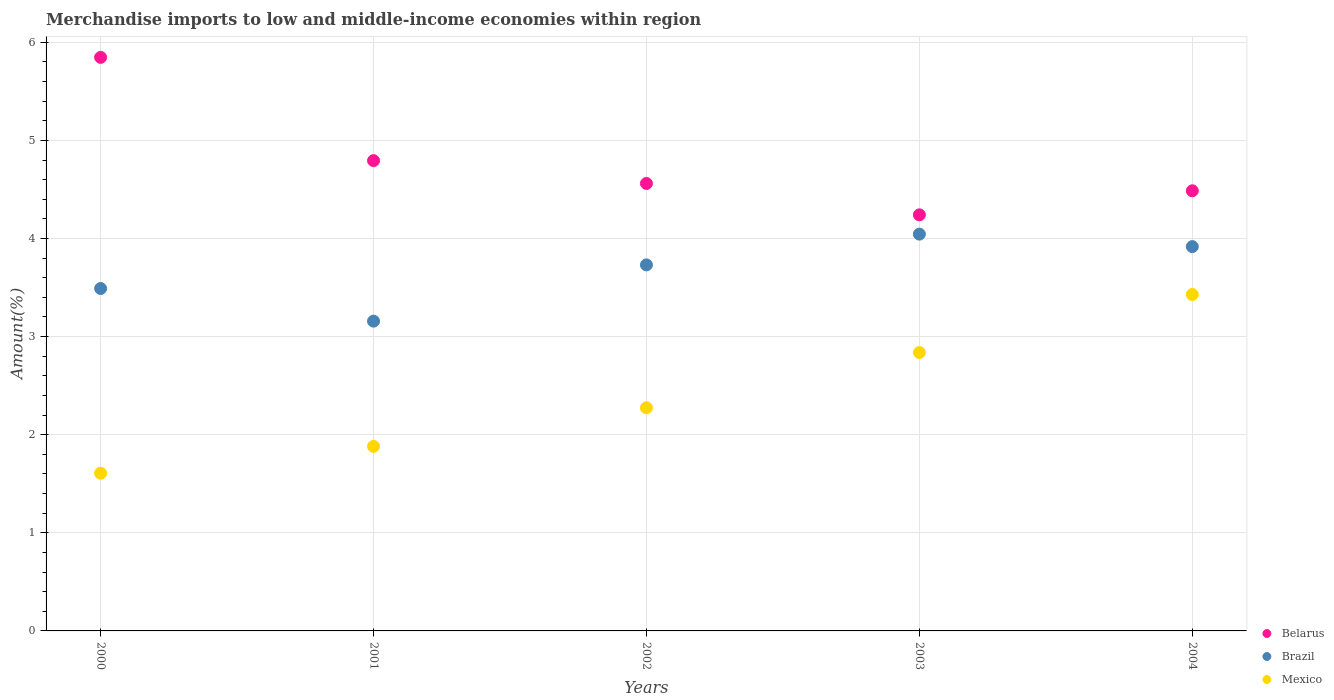Is the number of dotlines equal to the number of legend labels?
Offer a very short reply. Yes. What is the percentage of amount earned from merchandise imports in Brazil in 2004?
Your answer should be compact. 3.92. Across all years, what is the maximum percentage of amount earned from merchandise imports in Brazil?
Offer a very short reply. 4.04. Across all years, what is the minimum percentage of amount earned from merchandise imports in Mexico?
Give a very brief answer. 1.61. In which year was the percentage of amount earned from merchandise imports in Mexico maximum?
Your answer should be very brief. 2004. In which year was the percentage of amount earned from merchandise imports in Belarus minimum?
Your answer should be compact. 2003. What is the total percentage of amount earned from merchandise imports in Mexico in the graph?
Keep it short and to the point. 12.03. What is the difference between the percentage of amount earned from merchandise imports in Belarus in 2000 and that in 2004?
Give a very brief answer. 1.36. What is the difference between the percentage of amount earned from merchandise imports in Brazil in 2004 and the percentage of amount earned from merchandise imports in Mexico in 2003?
Make the answer very short. 1.08. What is the average percentage of amount earned from merchandise imports in Brazil per year?
Offer a very short reply. 3.67. In the year 2003, what is the difference between the percentage of amount earned from merchandise imports in Brazil and percentage of amount earned from merchandise imports in Belarus?
Ensure brevity in your answer.  -0.2. In how many years, is the percentage of amount earned from merchandise imports in Mexico greater than 2.4 %?
Give a very brief answer. 2. What is the ratio of the percentage of amount earned from merchandise imports in Mexico in 2001 to that in 2002?
Your answer should be very brief. 0.83. What is the difference between the highest and the second highest percentage of amount earned from merchandise imports in Mexico?
Offer a terse response. 0.59. What is the difference between the highest and the lowest percentage of amount earned from merchandise imports in Brazil?
Your answer should be very brief. 0.89. In how many years, is the percentage of amount earned from merchandise imports in Brazil greater than the average percentage of amount earned from merchandise imports in Brazil taken over all years?
Keep it short and to the point. 3. Does the percentage of amount earned from merchandise imports in Brazil monotonically increase over the years?
Give a very brief answer. No. Is the percentage of amount earned from merchandise imports in Brazil strictly less than the percentage of amount earned from merchandise imports in Mexico over the years?
Offer a terse response. No. How many years are there in the graph?
Provide a short and direct response. 5. Are the values on the major ticks of Y-axis written in scientific E-notation?
Ensure brevity in your answer.  No. Does the graph contain grids?
Offer a terse response. Yes. Where does the legend appear in the graph?
Keep it short and to the point. Bottom right. How many legend labels are there?
Offer a terse response. 3. How are the legend labels stacked?
Give a very brief answer. Vertical. What is the title of the graph?
Provide a short and direct response. Merchandise imports to low and middle-income economies within region. What is the label or title of the X-axis?
Your answer should be compact. Years. What is the label or title of the Y-axis?
Offer a terse response. Amount(%). What is the Amount(%) of Belarus in 2000?
Your response must be concise. 5.85. What is the Amount(%) in Brazil in 2000?
Ensure brevity in your answer.  3.49. What is the Amount(%) in Mexico in 2000?
Your answer should be very brief. 1.61. What is the Amount(%) of Belarus in 2001?
Provide a succinct answer. 4.79. What is the Amount(%) of Brazil in 2001?
Your answer should be compact. 3.16. What is the Amount(%) in Mexico in 2001?
Offer a very short reply. 1.88. What is the Amount(%) in Belarus in 2002?
Your answer should be compact. 4.56. What is the Amount(%) of Brazil in 2002?
Provide a succinct answer. 3.73. What is the Amount(%) in Mexico in 2002?
Your answer should be compact. 2.27. What is the Amount(%) in Belarus in 2003?
Offer a terse response. 4.24. What is the Amount(%) of Brazil in 2003?
Your answer should be very brief. 4.04. What is the Amount(%) in Mexico in 2003?
Keep it short and to the point. 2.84. What is the Amount(%) in Belarus in 2004?
Your answer should be very brief. 4.49. What is the Amount(%) in Brazil in 2004?
Your response must be concise. 3.92. What is the Amount(%) of Mexico in 2004?
Your response must be concise. 3.43. Across all years, what is the maximum Amount(%) of Belarus?
Offer a terse response. 5.85. Across all years, what is the maximum Amount(%) of Brazil?
Keep it short and to the point. 4.04. Across all years, what is the maximum Amount(%) of Mexico?
Provide a short and direct response. 3.43. Across all years, what is the minimum Amount(%) of Belarus?
Provide a short and direct response. 4.24. Across all years, what is the minimum Amount(%) in Brazil?
Your answer should be compact. 3.16. Across all years, what is the minimum Amount(%) of Mexico?
Your answer should be very brief. 1.61. What is the total Amount(%) in Belarus in the graph?
Your answer should be very brief. 23.93. What is the total Amount(%) of Brazil in the graph?
Your response must be concise. 18.34. What is the total Amount(%) of Mexico in the graph?
Provide a short and direct response. 12.03. What is the difference between the Amount(%) of Belarus in 2000 and that in 2001?
Your response must be concise. 1.05. What is the difference between the Amount(%) in Brazil in 2000 and that in 2001?
Provide a short and direct response. 0.33. What is the difference between the Amount(%) in Mexico in 2000 and that in 2001?
Your response must be concise. -0.27. What is the difference between the Amount(%) in Belarus in 2000 and that in 2002?
Give a very brief answer. 1.29. What is the difference between the Amount(%) in Brazil in 2000 and that in 2002?
Your answer should be compact. -0.24. What is the difference between the Amount(%) in Mexico in 2000 and that in 2002?
Your response must be concise. -0.67. What is the difference between the Amount(%) of Belarus in 2000 and that in 2003?
Give a very brief answer. 1.61. What is the difference between the Amount(%) in Brazil in 2000 and that in 2003?
Give a very brief answer. -0.55. What is the difference between the Amount(%) in Mexico in 2000 and that in 2003?
Your response must be concise. -1.23. What is the difference between the Amount(%) of Belarus in 2000 and that in 2004?
Give a very brief answer. 1.36. What is the difference between the Amount(%) of Brazil in 2000 and that in 2004?
Ensure brevity in your answer.  -0.43. What is the difference between the Amount(%) of Mexico in 2000 and that in 2004?
Keep it short and to the point. -1.82. What is the difference between the Amount(%) in Belarus in 2001 and that in 2002?
Ensure brevity in your answer.  0.23. What is the difference between the Amount(%) in Brazil in 2001 and that in 2002?
Offer a terse response. -0.57. What is the difference between the Amount(%) in Mexico in 2001 and that in 2002?
Offer a terse response. -0.39. What is the difference between the Amount(%) of Belarus in 2001 and that in 2003?
Provide a short and direct response. 0.55. What is the difference between the Amount(%) of Brazil in 2001 and that in 2003?
Your answer should be compact. -0.89. What is the difference between the Amount(%) of Mexico in 2001 and that in 2003?
Ensure brevity in your answer.  -0.96. What is the difference between the Amount(%) in Belarus in 2001 and that in 2004?
Your response must be concise. 0.31. What is the difference between the Amount(%) in Brazil in 2001 and that in 2004?
Provide a short and direct response. -0.76. What is the difference between the Amount(%) in Mexico in 2001 and that in 2004?
Provide a succinct answer. -1.55. What is the difference between the Amount(%) in Belarus in 2002 and that in 2003?
Provide a short and direct response. 0.32. What is the difference between the Amount(%) of Brazil in 2002 and that in 2003?
Offer a very short reply. -0.31. What is the difference between the Amount(%) in Mexico in 2002 and that in 2003?
Offer a terse response. -0.56. What is the difference between the Amount(%) in Belarus in 2002 and that in 2004?
Offer a very short reply. 0.07. What is the difference between the Amount(%) in Brazil in 2002 and that in 2004?
Keep it short and to the point. -0.19. What is the difference between the Amount(%) of Mexico in 2002 and that in 2004?
Provide a short and direct response. -1.15. What is the difference between the Amount(%) in Belarus in 2003 and that in 2004?
Keep it short and to the point. -0.25. What is the difference between the Amount(%) of Brazil in 2003 and that in 2004?
Your answer should be compact. 0.13. What is the difference between the Amount(%) in Mexico in 2003 and that in 2004?
Provide a succinct answer. -0.59. What is the difference between the Amount(%) of Belarus in 2000 and the Amount(%) of Brazil in 2001?
Give a very brief answer. 2.69. What is the difference between the Amount(%) in Belarus in 2000 and the Amount(%) in Mexico in 2001?
Provide a succinct answer. 3.97. What is the difference between the Amount(%) in Brazil in 2000 and the Amount(%) in Mexico in 2001?
Offer a very short reply. 1.61. What is the difference between the Amount(%) in Belarus in 2000 and the Amount(%) in Brazil in 2002?
Your answer should be compact. 2.12. What is the difference between the Amount(%) of Belarus in 2000 and the Amount(%) of Mexico in 2002?
Offer a terse response. 3.57. What is the difference between the Amount(%) in Brazil in 2000 and the Amount(%) in Mexico in 2002?
Offer a terse response. 1.22. What is the difference between the Amount(%) of Belarus in 2000 and the Amount(%) of Brazil in 2003?
Keep it short and to the point. 1.8. What is the difference between the Amount(%) of Belarus in 2000 and the Amount(%) of Mexico in 2003?
Make the answer very short. 3.01. What is the difference between the Amount(%) in Brazil in 2000 and the Amount(%) in Mexico in 2003?
Your answer should be compact. 0.65. What is the difference between the Amount(%) of Belarus in 2000 and the Amount(%) of Brazil in 2004?
Offer a terse response. 1.93. What is the difference between the Amount(%) in Belarus in 2000 and the Amount(%) in Mexico in 2004?
Your answer should be very brief. 2.42. What is the difference between the Amount(%) in Brazil in 2000 and the Amount(%) in Mexico in 2004?
Offer a terse response. 0.06. What is the difference between the Amount(%) of Belarus in 2001 and the Amount(%) of Brazil in 2002?
Provide a succinct answer. 1.06. What is the difference between the Amount(%) in Belarus in 2001 and the Amount(%) in Mexico in 2002?
Your answer should be very brief. 2.52. What is the difference between the Amount(%) of Brazil in 2001 and the Amount(%) of Mexico in 2002?
Your answer should be compact. 0.88. What is the difference between the Amount(%) of Belarus in 2001 and the Amount(%) of Brazil in 2003?
Keep it short and to the point. 0.75. What is the difference between the Amount(%) of Belarus in 2001 and the Amount(%) of Mexico in 2003?
Your answer should be compact. 1.96. What is the difference between the Amount(%) in Brazil in 2001 and the Amount(%) in Mexico in 2003?
Offer a terse response. 0.32. What is the difference between the Amount(%) of Belarus in 2001 and the Amount(%) of Brazil in 2004?
Keep it short and to the point. 0.88. What is the difference between the Amount(%) of Belarus in 2001 and the Amount(%) of Mexico in 2004?
Offer a very short reply. 1.36. What is the difference between the Amount(%) in Brazil in 2001 and the Amount(%) in Mexico in 2004?
Offer a very short reply. -0.27. What is the difference between the Amount(%) in Belarus in 2002 and the Amount(%) in Brazil in 2003?
Ensure brevity in your answer.  0.52. What is the difference between the Amount(%) in Belarus in 2002 and the Amount(%) in Mexico in 2003?
Your answer should be very brief. 1.72. What is the difference between the Amount(%) in Brazil in 2002 and the Amount(%) in Mexico in 2003?
Offer a very short reply. 0.89. What is the difference between the Amount(%) in Belarus in 2002 and the Amount(%) in Brazil in 2004?
Make the answer very short. 0.64. What is the difference between the Amount(%) in Belarus in 2002 and the Amount(%) in Mexico in 2004?
Offer a very short reply. 1.13. What is the difference between the Amount(%) in Brazil in 2002 and the Amount(%) in Mexico in 2004?
Offer a very short reply. 0.3. What is the difference between the Amount(%) of Belarus in 2003 and the Amount(%) of Brazil in 2004?
Offer a very short reply. 0.32. What is the difference between the Amount(%) of Belarus in 2003 and the Amount(%) of Mexico in 2004?
Your answer should be compact. 0.81. What is the difference between the Amount(%) of Brazil in 2003 and the Amount(%) of Mexico in 2004?
Give a very brief answer. 0.62. What is the average Amount(%) of Belarus per year?
Your answer should be compact. 4.79. What is the average Amount(%) in Brazil per year?
Make the answer very short. 3.67. What is the average Amount(%) in Mexico per year?
Give a very brief answer. 2.41. In the year 2000, what is the difference between the Amount(%) of Belarus and Amount(%) of Brazil?
Provide a short and direct response. 2.36. In the year 2000, what is the difference between the Amount(%) of Belarus and Amount(%) of Mexico?
Offer a very short reply. 4.24. In the year 2000, what is the difference between the Amount(%) in Brazil and Amount(%) in Mexico?
Keep it short and to the point. 1.88. In the year 2001, what is the difference between the Amount(%) in Belarus and Amount(%) in Brazil?
Ensure brevity in your answer.  1.64. In the year 2001, what is the difference between the Amount(%) of Belarus and Amount(%) of Mexico?
Provide a short and direct response. 2.91. In the year 2001, what is the difference between the Amount(%) of Brazil and Amount(%) of Mexico?
Offer a very short reply. 1.28. In the year 2002, what is the difference between the Amount(%) in Belarus and Amount(%) in Brazil?
Make the answer very short. 0.83. In the year 2002, what is the difference between the Amount(%) of Belarus and Amount(%) of Mexico?
Your answer should be very brief. 2.29. In the year 2002, what is the difference between the Amount(%) in Brazil and Amount(%) in Mexico?
Your answer should be very brief. 1.46. In the year 2003, what is the difference between the Amount(%) in Belarus and Amount(%) in Brazil?
Provide a short and direct response. 0.2. In the year 2003, what is the difference between the Amount(%) in Belarus and Amount(%) in Mexico?
Offer a terse response. 1.4. In the year 2003, what is the difference between the Amount(%) of Brazil and Amount(%) of Mexico?
Offer a terse response. 1.21. In the year 2004, what is the difference between the Amount(%) of Belarus and Amount(%) of Brazil?
Your answer should be very brief. 0.57. In the year 2004, what is the difference between the Amount(%) in Belarus and Amount(%) in Mexico?
Keep it short and to the point. 1.06. In the year 2004, what is the difference between the Amount(%) in Brazil and Amount(%) in Mexico?
Give a very brief answer. 0.49. What is the ratio of the Amount(%) of Belarus in 2000 to that in 2001?
Ensure brevity in your answer.  1.22. What is the ratio of the Amount(%) of Brazil in 2000 to that in 2001?
Give a very brief answer. 1.11. What is the ratio of the Amount(%) of Mexico in 2000 to that in 2001?
Offer a terse response. 0.85. What is the ratio of the Amount(%) of Belarus in 2000 to that in 2002?
Keep it short and to the point. 1.28. What is the ratio of the Amount(%) in Brazil in 2000 to that in 2002?
Give a very brief answer. 0.94. What is the ratio of the Amount(%) in Mexico in 2000 to that in 2002?
Ensure brevity in your answer.  0.71. What is the ratio of the Amount(%) of Belarus in 2000 to that in 2003?
Give a very brief answer. 1.38. What is the ratio of the Amount(%) in Brazil in 2000 to that in 2003?
Your response must be concise. 0.86. What is the ratio of the Amount(%) in Mexico in 2000 to that in 2003?
Offer a very short reply. 0.57. What is the ratio of the Amount(%) in Belarus in 2000 to that in 2004?
Your response must be concise. 1.3. What is the ratio of the Amount(%) of Brazil in 2000 to that in 2004?
Provide a succinct answer. 0.89. What is the ratio of the Amount(%) in Mexico in 2000 to that in 2004?
Provide a short and direct response. 0.47. What is the ratio of the Amount(%) of Belarus in 2001 to that in 2002?
Keep it short and to the point. 1.05. What is the ratio of the Amount(%) in Brazil in 2001 to that in 2002?
Your response must be concise. 0.85. What is the ratio of the Amount(%) of Mexico in 2001 to that in 2002?
Your answer should be compact. 0.83. What is the ratio of the Amount(%) in Belarus in 2001 to that in 2003?
Provide a short and direct response. 1.13. What is the ratio of the Amount(%) in Brazil in 2001 to that in 2003?
Your answer should be very brief. 0.78. What is the ratio of the Amount(%) in Mexico in 2001 to that in 2003?
Keep it short and to the point. 0.66. What is the ratio of the Amount(%) in Belarus in 2001 to that in 2004?
Give a very brief answer. 1.07. What is the ratio of the Amount(%) of Brazil in 2001 to that in 2004?
Give a very brief answer. 0.81. What is the ratio of the Amount(%) in Mexico in 2001 to that in 2004?
Make the answer very short. 0.55. What is the ratio of the Amount(%) of Belarus in 2002 to that in 2003?
Keep it short and to the point. 1.08. What is the ratio of the Amount(%) in Brazil in 2002 to that in 2003?
Ensure brevity in your answer.  0.92. What is the ratio of the Amount(%) of Mexico in 2002 to that in 2003?
Your answer should be compact. 0.8. What is the ratio of the Amount(%) in Belarus in 2002 to that in 2004?
Keep it short and to the point. 1.02. What is the ratio of the Amount(%) of Brazil in 2002 to that in 2004?
Your answer should be compact. 0.95. What is the ratio of the Amount(%) of Mexico in 2002 to that in 2004?
Ensure brevity in your answer.  0.66. What is the ratio of the Amount(%) in Belarus in 2003 to that in 2004?
Offer a terse response. 0.95. What is the ratio of the Amount(%) of Brazil in 2003 to that in 2004?
Your answer should be compact. 1.03. What is the ratio of the Amount(%) of Mexico in 2003 to that in 2004?
Keep it short and to the point. 0.83. What is the difference between the highest and the second highest Amount(%) in Belarus?
Offer a very short reply. 1.05. What is the difference between the highest and the second highest Amount(%) in Brazil?
Offer a terse response. 0.13. What is the difference between the highest and the second highest Amount(%) of Mexico?
Make the answer very short. 0.59. What is the difference between the highest and the lowest Amount(%) of Belarus?
Your answer should be very brief. 1.61. What is the difference between the highest and the lowest Amount(%) of Brazil?
Provide a succinct answer. 0.89. What is the difference between the highest and the lowest Amount(%) of Mexico?
Keep it short and to the point. 1.82. 